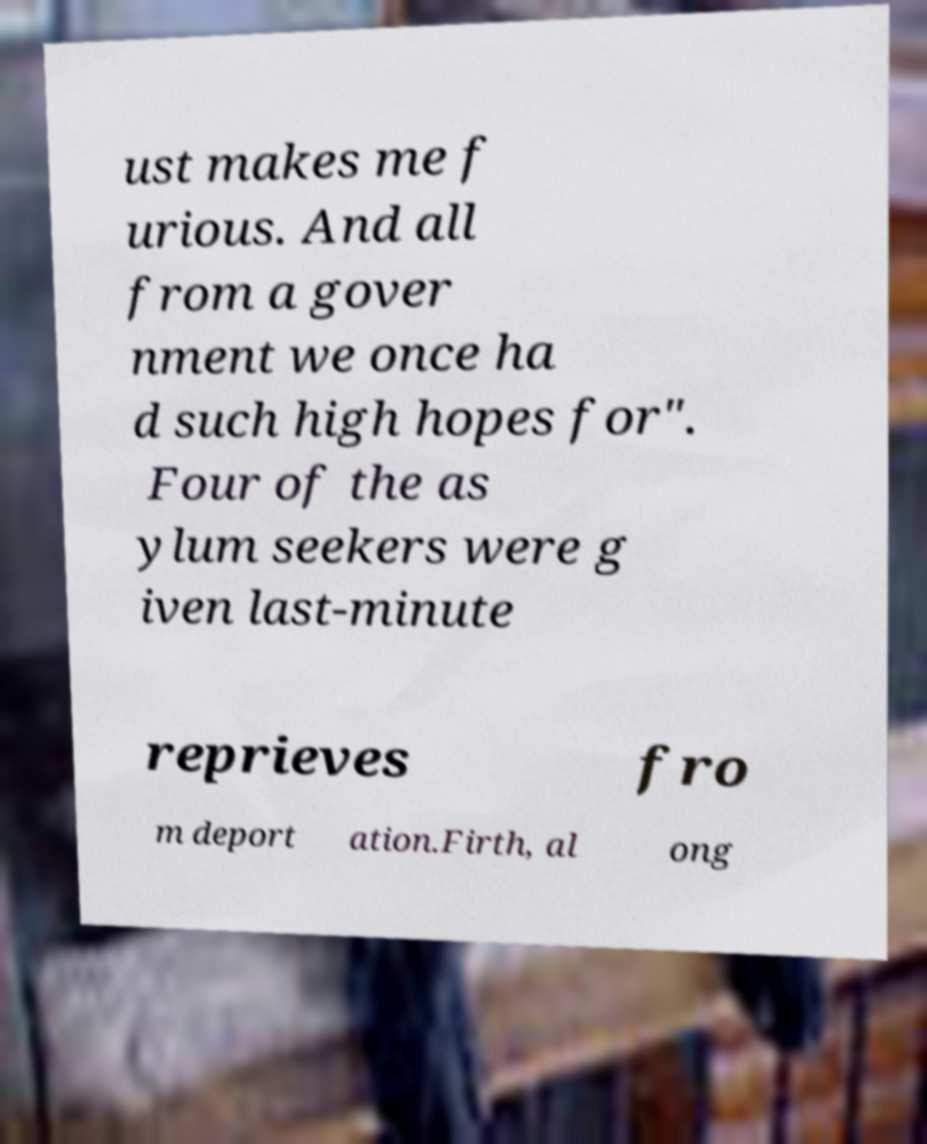Please identify and transcribe the text found in this image. ust makes me f urious. And all from a gover nment we once ha d such high hopes for". Four of the as ylum seekers were g iven last-minute reprieves fro m deport ation.Firth, al ong 